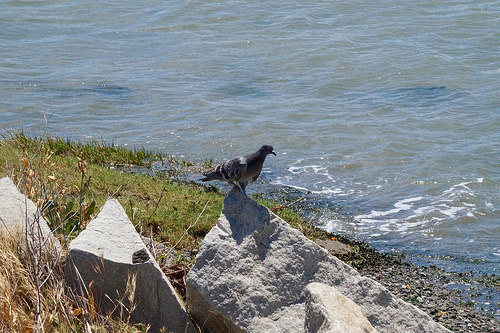<image>
Is the bird behind the water? No. The bird is not behind the water. From this viewpoint, the bird appears to be positioned elsewhere in the scene. Is the bird in the water? No. The bird is not contained within the water. These objects have a different spatial relationship. Is there a bird above the rock? Yes. The bird is positioned above the rock in the vertical space, higher up in the scene. 